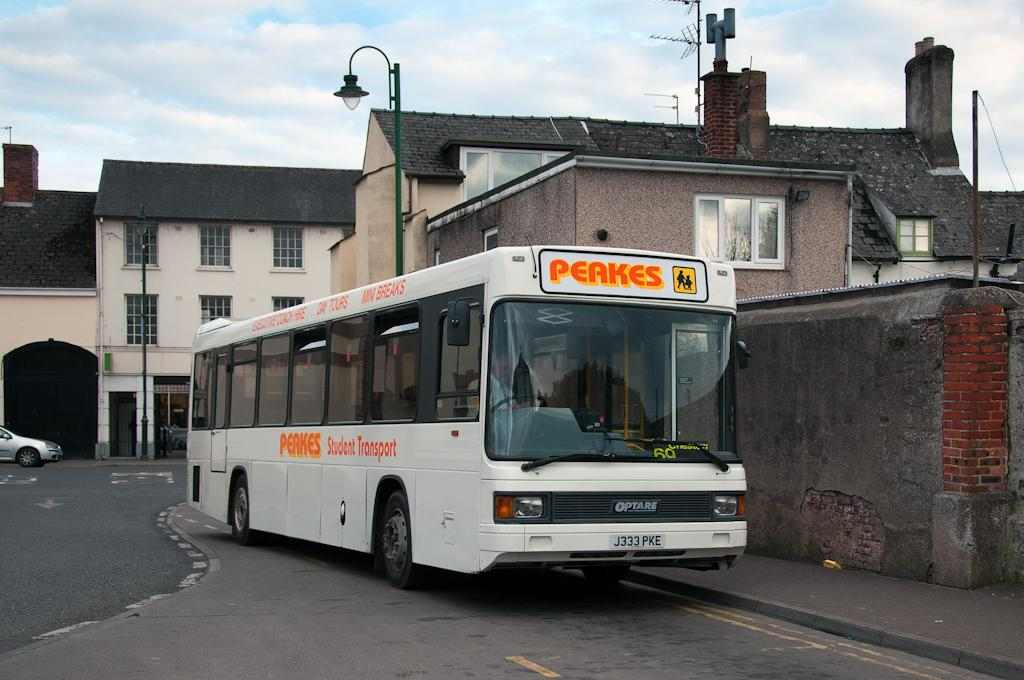What type of vehicle is in the image? There is a white color bus in the image. What is the bus doing in the image? The bus is moving on the road. What can be seen in the background of the image? There are shed houses with white color windows in the background. What are the tall, thin structures visible in the image? There are some antennas visible in the image. What part of the natural environment is visible in the image? The sky is visible in the image. Can you see a bear walking on the sidewalk in the image? There is no bear or sidewalk present in the image. What type of pleasure can be seen being derived from the bus ride in the image? The image does not show any indication of pleasure being derived from the bus ride; it only shows the bus moving on the road. 